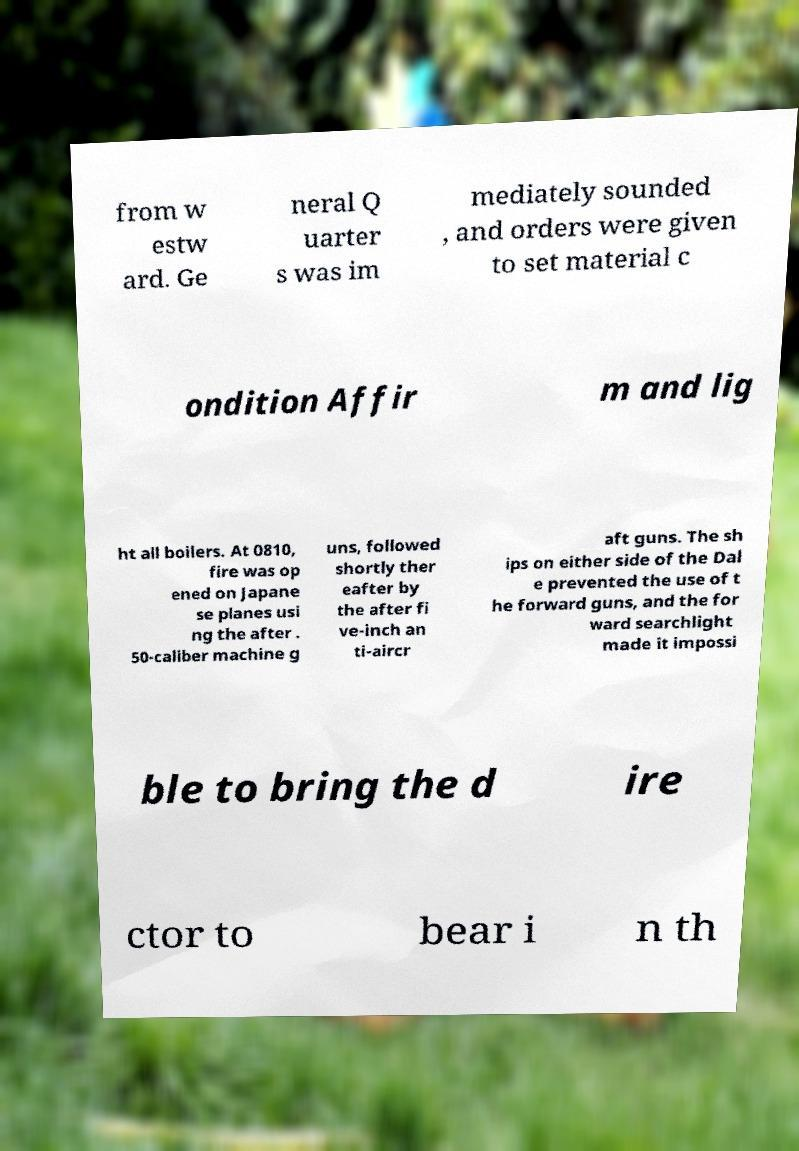Can you read and provide the text displayed in the image?This photo seems to have some interesting text. Can you extract and type it out for me? from w estw ard. Ge neral Q uarter s was im mediately sounded , and orders were given to set material c ondition Affir m and lig ht all boilers. At 0810, fire was op ened on Japane se planes usi ng the after . 50-caliber machine g uns, followed shortly ther eafter by the after fi ve-inch an ti-aircr aft guns. The sh ips on either side of the Dal e prevented the use of t he forward guns, and the for ward searchlight made it impossi ble to bring the d ire ctor to bear i n th 